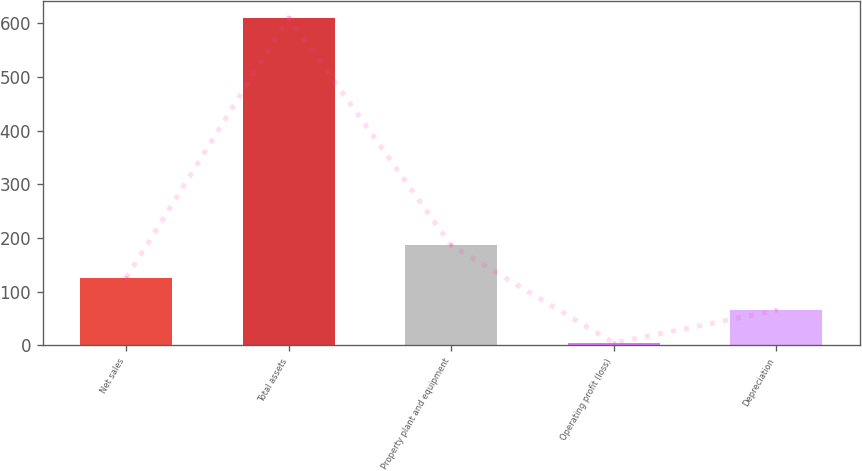<chart> <loc_0><loc_0><loc_500><loc_500><bar_chart><fcel>Net sales<fcel>Total assets<fcel>Property plant and equipment<fcel>Operating profit (loss)<fcel>Depreciation<nl><fcel>125.4<fcel>611<fcel>186.1<fcel>4<fcel>64.7<nl></chart> 